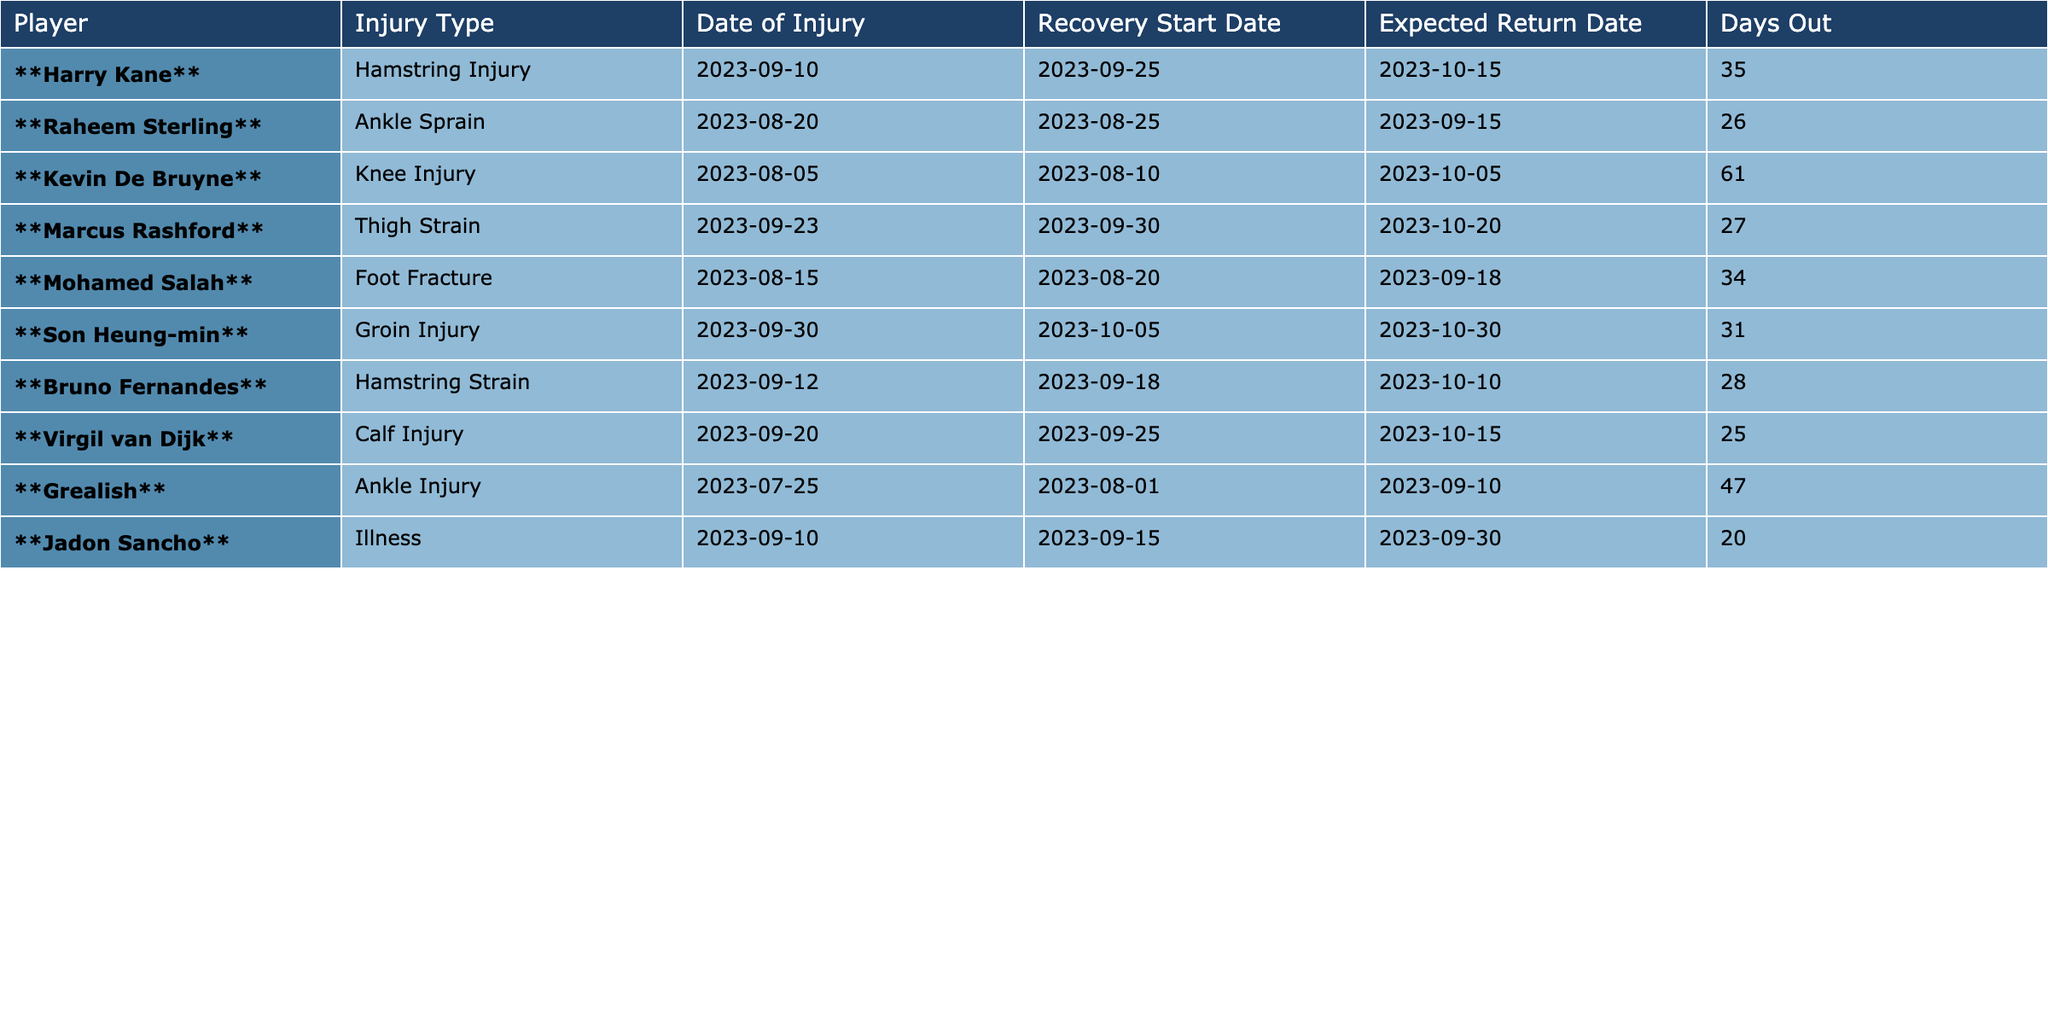What is the injury type for Harry Kane? The table shows that Harry Kane has a hamstring injury listed under the "Injury Type" column.
Answer: Hamstring Injury How many days is Raheem Sterling expected to be out? The table indicates that Raheem Sterling is expected to be out for 26 days, as mentioned in the "Days Out" column.
Answer: 26 days Who is suffering from a knee injury? The table lists Kevin De Bruyne under the "Injury Type" column with a knee injury.
Answer: Kevin De Bruyne What is the expected return date for Mohamed Salah? According to the table, Mohamed Salah's expected return date is 2023-09-18, listed under the "Expected Return Date" column.
Answer: 2023-09-18 Which player is recovering from a calf injury? The table reveals that Virgil van Dijk is the player recovering from a calf injury under the "Injury Type" column.
Answer: Virgil van Dijk What is the total number of days out for all players combined? By adding the days out for each player: 35 + 26 + 61 + 27 + 34 + 31 + 28 + 25 + 47 + 20 =  364 days out in total for all players.
Answer: 364 days Who has the longest expected recovery time? Kevin De Bruyne has the longest expected recovery time of 61 days as indicated in the "Days Out" column.
Answer: Kevin De Bruyne Which player has an ankle injury that is expected to keep him out for the least amount of time? Raheem Sterling has an ankle sprain that is expected to keep him out for 26 days, which is the least amount of time compared to all other players.
Answer: Raheem Sterling Is there any player expected to return before September 30? Yes, both Raheem Sterling and Mohamed Salah are among players expected to return before September 30, 2023.
Answer: Yes How many players are expected to return after October 15? Two players, Kevin De Bruyne (October 5) and Son Heung-min (October 30), are expected to return after October 15. Counts confirm this logic.
Answer: 1 player 